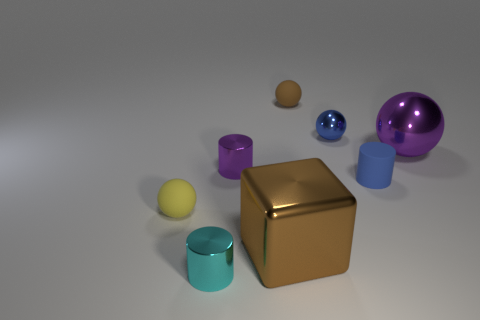What number of other small metal things are the same shape as the small cyan metallic object? 1 